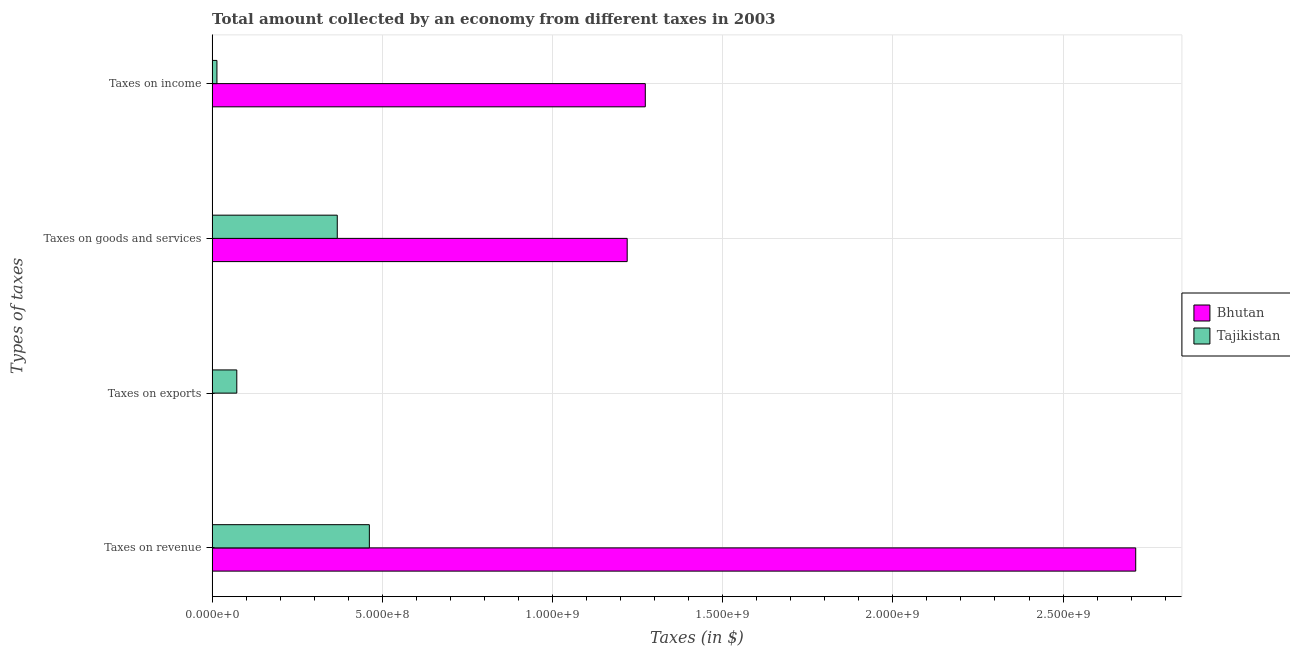How many groups of bars are there?
Offer a very short reply. 4. What is the label of the 2nd group of bars from the top?
Your answer should be compact. Taxes on goods and services. What is the amount collected as tax on goods in Bhutan?
Your response must be concise. 1.22e+09. Across all countries, what is the maximum amount collected as tax on income?
Your answer should be compact. 1.27e+09. Across all countries, what is the minimum amount collected as tax on income?
Make the answer very short. 1.42e+07. In which country was the amount collected as tax on income maximum?
Give a very brief answer. Bhutan. In which country was the amount collected as tax on income minimum?
Offer a very short reply. Tajikistan. What is the total amount collected as tax on goods in the graph?
Your response must be concise. 1.59e+09. What is the difference between the amount collected as tax on goods in Bhutan and that in Tajikistan?
Provide a succinct answer. 8.52e+08. What is the difference between the amount collected as tax on income in Tajikistan and the amount collected as tax on revenue in Bhutan?
Offer a very short reply. -2.70e+09. What is the average amount collected as tax on exports per country?
Your response must be concise. 3.66e+07. What is the difference between the amount collected as tax on goods and amount collected as tax on income in Bhutan?
Give a very brief answer. -5.32e+07. What is the ratio of the amount collected as tax on goods in Bhutan to that in Tajikistan?
Keep it short and to the point. 3.32. Is the difference between the amount collected as tax on revenue in Bhutan and Tajikistan greater than the difference between the amount collected as tax on exports in Bhutan and Tajikistan?
Ensure brevity in your answer.  Yes. What is the difference between the highest and the second highest amount collected as tax on goods?
Make the answer very short. 8.52e+08. What is the difference between the highest and the lowest amount collected as tax on exports?
Your answer should be very brief. 7.17e+07. What does the 2nd bar from the top in Taxes on exports represents?
Offer a terse response. Bhutan. What does the 1st bar from the bottom in Taxes on income represents?
Provide a succinct answer. Bhutan. Are all the bars in the graph horizontal?
Provide a succinct answer. Yes. How many countries are there in the graph?
Your answer should be compact. 2. Does the graph contain any zero values?
Offer a very short reply. No. Does the graph contain grids?
Provide a succinct answer. Yes. Where does the legend appear in the graph?
Give a very brief answer. Center right. What is the title of the graph?
Your answer should be compact. Total amount collected by an economy from different taxes in 2003. What is the label or title of the X-axis?
Offer a very short reply. Taxes (in $). What is the label or title of the Y-axis?
Provide a succinct answer. Types of taxes. What is the Taxes (in $) in Bhutan in Taxes on revenue?
Provide a succinct answer. 2.71e+09. What is the Taxes (in $) of Tajikistan in Taxes on revenue?
Offer a terse response. 4.62e+08. What is the Taxes (in $) in Bhutan in Taxes on exports?
Offer a very short reply. 7.63e+05. What is the Taxes (in $) of Tajikistan in Taxes on exports?
Your answer should be very brief. 7.25e+07. What is the Taxes (in $) in Bhutan in Taxes on goods and services?
Offer a very short reply. 1.22e+09. What is the Taxes (in $) in Tajikistan in Taxes on goods and services?
Provide a succinct answer. 3.68e+08. What is the Taxes (in $) in Bhutan in Taxes on income?
Your response must be concise. 1.27e+09. What is the Taxes (in $) in Tajikistan in Taxes on income?
Your answer should be very brief. 1.42e+07. Across all Types of taxes, what is the maximum Taxes (in $) of Bhutan?
Provide a short and direct response. 2.71e+09. Across all Types of taxes, what is the maximum Taxes (in $) in Tajikistan?
Your answer should be compact. 4.62e+08. Across all Types of taxes, what is the minimum Taxes (in $) of Bhutan?
Make the answer very short. 7.63e+05. Across all Types of taxes, what is the minimum Taxes (in $) of Tajikistan?
Your answer should be compact. 1.42e+07. What is the total Taxes (in $) in Bhutan in the graph?
Give a very brief answer. 5.21e+09. What is the total Taxes (in $) in Tajikistan in the graph?
Provide a succinct answer. 9.16e+08. What is the difference between the Taxes (in $) of Bhutan in Taxes on revenue and that in Taxes on exports?
Provide a short and direct response. 2.71e+09. What is the difference between the Taxes (in $) of Tajikistan in Taxes on revenue and that in Taxes on exports?
Provide a succinct answer. 3.89e+08. What is the difference between the Taxes (in $) in Bhutan in Taxes on revenue and that in Taxes on goods and services?
Provide a short and direct response. 1.49e+09. What is the difference between the Taxes (in $) in Tajikistan in Taxes on revenue and that in Taxes on goods and services?
Ensure brevity in your answer.  9.43e+07. What is the difference between the Taxes (in $) of Bhutan in Taxes on revenue and that in Taxes on income?
Make the answer very short. 1.44e+09. What is the difference between the Taxes (in $) in Tajikistan in Taxes on revenue and that in Taxes on income?
Ensure brevity in your answer.  4.48e+08. What is the difference between the Taxes (in $) in Bhutan in Taxes on exports and that in Taxes on goods and services?
Provide a succinct answer. -1.22e+09. What is the difference between the Taxes (in $) in Tajikistan in Taxes on exports and that in Taxes on goods and services?
Give a very brief answer. -2.95e+08. What is the difference between the Taxes (in $) of Bhutan in Taxes on exports and that in Taxes on income?
Ensure brevity in your answer.  -1.27e+09. What is the difference between the Taxes (in $) in Tajikistan in Taxes on exports and that in Taxes on income?
Provide a short and direct response. 5.83e+07. What is the difference between the Taxes (in $) in Bhutan in Taxes on goods and services and that in Taxes on income?
Ensure brevity in your answer.  -5.32e+07. What is the difference between the Taxes (in $) in Tajikistan in Taxes on goods and services and that in Taxes on income?
Give a very brief answer. 3.54e+08. What is the difference between the Taxes (in $) in Bhutan in Taxes on revenue and the Taxes (in $) in Tajikistan in Taxes on exports?
Provide a short and direct response. 2.64e+09. What is the difference between the Taxes (in $) of Bhutan in Taxes on revenue and the Taxes (in $) of Tajikistan in Taxes on goods and services?
Offer a very short reply. 2.35e+09. What is the difference between the Taxes (in $) in Bhutan in Taxes on revenue and the Taxes (in $) in Tajikistan in Taxes on income?
Keep it short and to the point. 2.70e+09. What is the difference between the Taxes (in $) of Bhutan in Taxes on exports and the Taxes (in $) of Tajikistan in Taxes on goods and services?
Give a very brief answer. -3.67e+08. What is the difference between the Taxes (in $) of Bhutan in Taxes on exports and the Taxes (in $) of Tajikistan in Taxes on income?
Your answer should be compact. -1.34e+07. What is the difference between the Taxes (in $) in Bhutan in Taxes on goods and services and the Taxes (in $) in Tajikistan in Taxes on income?
Your response must be concise. 1.21e+09. What is the average Taxes (in $) in Bhutan per Types of taxes?
Ensure brevity in your answer.  1.30e+09. What is the average Taxes (in $) in Tajikistan per Types of taxes?
Ensure brevity in your answer.  2.29e+08. What is the difference between the Taxes (in $) in Bhutan and Taxes (in $) in Tajikistan in Taxes on revenue?
Provide a succinct answer. 2.25e+09. What is the difference between the Taxes (in $) in Bhutan and Taxes (in $) in Tajikistan in Taxes on exports?
Your response must be concise. -7.17e+07. What is the difference between the Taxes (in $) of Bhutan and Taxes (in $) of Tajikistan in Taxes on goods and services?
Your response must be concise. 8.52e+08. What is the difference between the Taxes (in $) in Bhutan and Taxes (in $) in Tajikistan in Taxes on income?
Your response must be concise. 1.26e+09. What is the ratio of the Taxes (in $) of Bhutan in Taxes on revenue to that in Taxes on exports?
Offer a terse response. 3556.44. What is the ratio of the Taxes (in $) in Tajikistan in Taxes on revenue to that in Taxes on exports?
Offer a terse response. 6.37. What is the ratio of the Taxes (in $) in Bhutan in Taxes on revenue to that in Taxes on goods and services?
Offer a very short reply. 2.23. What is the ratio of the Taxes (in $) in Tajikistan in Taxes on revenue to that in Taxes on goods and services?
Your answer should be compact. 1.26. What is the ratio of the Taxes (in $) in Bhutan in Taxes on revenue to that in Taxes on income?
Your answer should be compact. 2.13. What is the ratio of the Taxes (in $) of Tajikistan in Taxes on revenue to that in Taxes on income?
Provide a succinct answer. 32.62. What is the ratio of the Taxes (in $) of Bhutan in Taxes on exports to that in Taxes on goods and services?
Offer a terse response. 0. What is the ratio of the Taxes (in $) of Tajikistan in Taxes on exports to that in Taxes on goods and services?
Keep it short and to the point. 0.2. What is the ratio of the Taxes (in $) of Bhutan in Taxes on exports to that in Taxes on income?
Your answer should be very brief. 0. What is the ratio of the Taxes (in $) in Tajikistan in Taxes on exports to that in Taxes on income?
Make the answer very short. 5.12. What is the ratio of the Taxes (in $) of Bhutan in Taxes on goods and services to that in Taxes on income?
Your response must be concise. 0.96. What is the ratio of the Taxes (in $) of Tajikistan in Taxes on goods and services to that in Taxes on income?
Offer a terse response. 25.96. What is the difference between the highest and the second highest Taxes (in $) in Bhutan?
Your response must be concise. 1.44e+09. What is the difference between the highest and the second highest Taxes (in $) in Tajikistan?
Provide a succinct answer. 9.43e+07. What is the difference between the highest and the lowest Taxes (in $) of Bhutan?
Offer a very short reply. 2.71e+09. What is the difference between the highest and the lowest Taxes (in $) of Tajikistan?
Make the answer very short. 4.48e+08. 